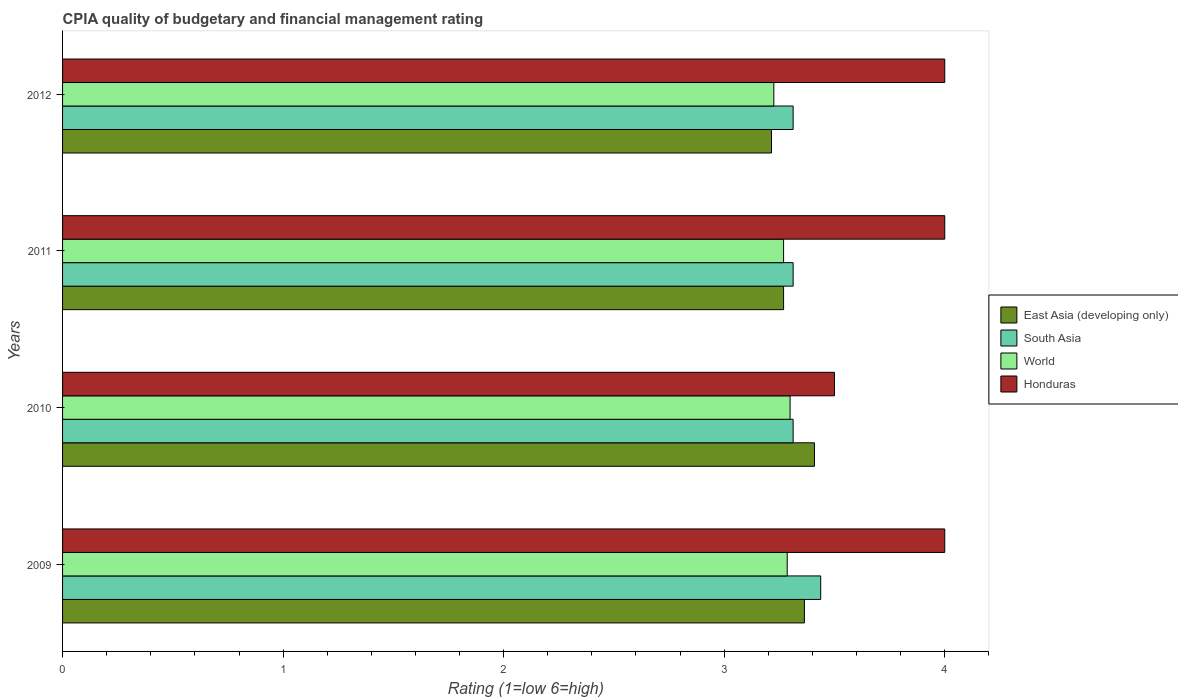How many bars are there on the 3rd tick from the top?
Offer a terse response. 4. What is the label of the 4th group of bars from the top?
Give a very brief answer. 2009. In how many cases, is the number of bars for a given year not equal to the number of legend labels?
Offer a very short reply. 0. What is the CPIA rating in Honduras in 2011?
Keep it short and to the point. 4. Across all years, what is the maximum CPIA rating in South Asia?
Provide a succinct answer. 3.44. Across all years, what is the minimum CPIA rating in World?
Offer a very short reply. 3.23. In which year was the CPIA rating in South Asia maximum?
Your response must be concise. 2009. In which year was the CPIA rating in Honduras minimum?
Provide a succinct answer. 2010. What is the difference between the CPIA rating in South Asia in 2009 and that in 2012?
Your answer should be very brief. 0.12. What is the difference between the CPIA rating in South Asia in 2009 and the CPIA rating in World in 2011?
Provide a short and direct response. 0.17. What is the average CPIA rating in Honduras per year?
Your response must be concise. 3.88. In the year 2011, what is the difference between the CPIA rating in World and CPIA rating in South Asia?
Ensure brevity in your answer.  -0.04. What is the ratio of the CPIA rating in World in 2009 to that in 2011?
Your answer should be compact. 1.01. Is the difference between the CPIA rating in World in 2009 and 2011 greater than the difference between the CPIA rating in South Asia in 2009 and 2011?
Provide a short and direct response. No. What is the difference between the highest and the second highest CPIA rating in East Asia (developing only)?
Keep it short and to the point. 0.05. Is the sum of the CPIA rating in World in 2009 and 2010 greater than the maximum CPIA rating in East Asia (developing only) across all years?
Offer a terse response. Yes. Is it the case that in every year, the sum of the CPIA rating in South Asia and CPIA rating in East Asia (developing only) is greater than the sum of CPIA rating in World and CPIA rating in Honduras?
Give a very brief answer. No. What does the 2nd bar from the top in 2009 represents?
Make the answer very short. World. What does the 4th bar from the bottom in 2009 represents?
Offer a terse response. Honduras. Is it the case that in every year, the sum of the CPIA rating in World and CPIA rating in South Asia is greater than the CPIA rating in East Asia (developing only)?
Your response must be concise. Yes. How many bars are there?
Keep it short and to the point. 16. Are the values on the major ticks of X-axis written in scientific E-notation?
Offer a terse response. No. Where does the legend appear in the graph?
Make the answer very short. Center right. How are the legend labels stacked?
Your answer should be compact. Vertical. What is the title of the graph?
Provide a short and direct response. CPIA quality of budgetary and financial management rating. Does "Guatemala" appear as one of the legend labels in the graph?
Your answer should be compact. No. What is the label or title of the X-axis?
Offer a terse response. Rating (1=low 6=high). What is the label or title of the Y-axis?
Provide a succinct answer. Years. What is the Rating (1=low 6=high) of East Asia (developing only) in 2009?
Offer a very short reply. 3.36. What is the Rating (1=low 6=high) in South Asia in 2009?
Your answer should be very brief. 3.44. What is the Rating (1=low 6=high) in World in 2009?
Your answer should be very brief. 3.29. What is the Rating (1=low 6=high) of Honduras in 2009?
Provide a succinct answer. 4. What is the Rating (1=low 6=high) in East Asia (developing only) in 2010?
Give a very brief answer. 3.41. What is the Rating (1=low 6=high) in South Asia in 2010?
Offer a terse response. 3.31. What is the Rating (1=low 6=high) in World in 2010?
Your response must be concise. 3.3. What is the Rating (1=low 6=high) in East Asia (developing only) in 2011?
Provide a short and direct response. 3.27. What is the Rating (1=low 6=high) of South Asia in 2011?
Ensure brevity in your answer.  3.31. What is the Rating (1=low 6=high) in World in 2011?
Provide a short and direct response. 3.27. What is the Rating (1=low 6=high) in East Asia (developing only) in 2012?
Give a very brief answer. 3.21. What is the Rating (1=low 6=high) of South Asia in 2012?
Provide a short and direct response. 3.31. What is the Rating (1=low 6=high) of World in 2012?
Ensure brevity in your answer.  3.23. What is the Rating (1=low 6=high) of Honduras in 2012?
Make the answer very short. 4. Across all years, what is the maximum Rating (1=low 6=high) of East Asia (developing only)?
Keep it short and to the point. 3.41. Across all years, what is the maximum Rating (1=low 6=high) in South Asia?
Offer a very short reply. 3.44. Across all years, what is the maximum Rating (1=low 6=high) in World?
Offer a very short reply. 3.3. Across all years, what is the minimum Rating (1=low 6=high) in East Asia (developing only)?
Offer a terse response. 3.21. Across all years, what is the minimum Rating (1=low 6=high) of South Asia?
Your response must be concise. 3.31. Across all years, what is the minimum Rating (1=low 6=high) of World?
Offer a terse response. 3.23. Across all years, what is the minimum Rating (1=low 6=high) of Honduras?
Ensure brevity in your answer.  3.5. What is the total Rating (1=low 6=high) of East Asia (developing only) in the graph?
Provide a succinct answer. 13.26. What is the total Rating (1=low 6=high) of South Asia in the graph?
Make the answer very short. 13.38. What is the total Rating (1=low 6=high) of World in the graph?
Offer a terse response. 13.08. What is the total Rating (1=low 6=high) in Honduras in the graph?
Offer a very short reply. 15.5. What is the difference between the Rating (1=low 6=high) of East Asia (developing only) in 2009 and that in 2010?
Your response must be concise. -0.05. What is the difference between the Rating (1=low 6=high) of South Asia in 2009 and that in 2010?
Make the answer very short. 0.12. What is the difference between the Rating (1=low 6=high) in World in 2009 and that in 2010?
Provide a succinct answer. -0.01. What is the difference between the Rating (1=low 6=high) of East Asia (developing only) in 2009 and that in 2011?
Ensure brevity in your answer.  0.09. What is the difference between the Rating (1=low 6=high) of South Asia in 2009 and that in 2011?
Provide a short and direct response. 0.12. What is the difference between the Rating (1=low 6=high) in World in 2009 and that in 2011?
Give a very brief answer. 0.02. What is the difference between the Rating (1=low 6=high) in East Asia (developing only) in 2009 and that in 2012?
Give a very brief answer. 0.15. What is the difference between the Rating (1=low 6=high) of World in 2009 and that in 2012?
Offer a terse response. 0.06. What is the difference between the Rating (1=low 6=high) in East Asia (developing only) in 2010 and that in 2011?
Keep it short and to the point. 0.14. What is the difference between the Rating (1=low 6=high) of World in 2010 and that in 2011?
Offer a terse response. 0.03. What is the difference between the Rating (1=low 6=high) of East Asia (developing only) in 2010 and that in 2012?
Offer a terse response. 0.19. What is the difference between the Rating (1=low 6=high) of South Asia in 2010 and that in 2012?
Provide a succinct answer. 0. What is the difference between the Rating (1=low 6=high) in World in 2010 and that in 2012?
Provide a short and direct response. 0.07. What is the difference between the Rating (1=low 6=high) in East Asia (developing only) in 2011 and that in 2012?
Provide a succinct answer. 0.05. What is the difference between the Rating (1=low 6=high) in South Asia in 2011 and that in 2012?
Provide a short and direct response. 0. What is the difference between the Rating (1=low 6=high) in World in 2011 and that in 2012?
Your answer should be compact. 0.04. What is the difference between the Rating (1=low 6=high) in Honduras in 2011 and that in 2012?
Your response must be concise. 0. What is the difference between the Rating (1=low 6=high) of East Asia (developing only) in 2009 and the Rating (1=low 6=high) of South Asia in 2010?
Your response must be concise. 0.05. What is the difference between the Rating (1=low 6=high) of East Asia (developing only) in 2009 and the Rating (1=low 6=high) of World in 2010?
Make the answer very short. 0.06. What is the difference between the Rating (1=low 6=high) in East Asia (developing only) in 2009 and the Rating (1=low 6=high) in Honduras in 2010?
Keep it short and to the point. -0.14. What is the difference between the Rating (1=low 6=high) in South Asia in 2009 and the Rating (1=low 6=high) in World in 2010?
Offer a terse response. 0.14. What is the difference between the Rating (1=low 6=high) of South Asia in 2009 and the Rating (1=low 6=high) of Honduras in 2010?
Provide a succinct answer. -0.06. What is the difference between the Rating (1=low 6=high) of World in 2009 and the Rating (1=low 6=high) of Honduras in 2010?
Offer a terse response. -0.21. What is the difference between the Rating (1=low 6=high) in East Asia (developing only) in 2009 and the Rating (1=low 6=high) in South Asia in 2011?
Offer a very short reply. 0.05. What is the difference between the Rating (1=low 6=high) of East Asia (developing only) in 2009 and the Rating (1=low 6=high) of World in 2011?
Your answer should be compact. 0.09. What is the difference between the Rating (1=low 6=high) in East Asia (developing only) in 2009 and the Rating (1=low 6=high) in Honduras in 2011?
Make the answer very short. -0.64. What is the difference between the Rating (1=low 6=high) in South Asia in 2009 and the Rating (1=low 6=high) in World in 2011?
Ensure brevity in your answer.  0.17. What is the difference between the Rating (1=low 6=high) of South Asia in 2009 and the Rating (1=low 6=high) of Honduras in 2011?
Offer a very short reply. -0.56. What is the difference between the Rating (1=low 6=high) in World in 2009 and the Rating (1=low 6=high) in Honduras in 2011?
Offer a terse response. -0.71. What is the difference between the Rating (1=low 6=high) in East Asia (developing only) in 2009 and the Rating (1=low 6=high) in South Asia in 2012?
Give a very brief answer. 0.05. What is the difference between the Rating (1=low 6=high) of East Asia (developing only) in 2009 and the Rating (1=low 6=high) of World in 2012?
Your answer should be compact. 0.14. What is the difference between the Rating (1=low 6=high) in East Asia (developing only) in 2009 and the Rating (1=low 6=high) in Honduras in 2012?
Give a very brief answer. -0.64. What is the difference between the Rating (1=low 6=high) of South Asia in 2009 and the Rating (1=low 6=high) of World in 2012?
Provide a succinct answer. 0.21. What is the difference between the Rating (1=low 6=high) of South Asia in 2009 and the Rating (1=low 6=high) of Honduras in 2012?
Give a very brief answer. -0.56. What is the difference between the Rating (1=low 6=high) in World in 2009 and the Rating (1=low 6=high) in Honduras in 2012?
Make the answer very short. -0.71. What is the difference between the Rating (1=low 6=high) of East Asia (developing only) in 2010 and the Rating (1=low 6=high) of South Asia in 2011?
Your answer should be compact. 0.1. What is the difference between the Rating (1=low 6=high) of East Asia (developing only) in 2010 and the Rating (1=low 6=high) of World in 2011?
Keep it short and to the point. 0.14. What is the difference between the Rating (1=low 6=high) in East Asia (developing only) in 2010 and the Rating (1=low 6=high) in Honduras in 2011?
Keep it short and to the point. -0.59. What is the difference between the Rating (1=low 6=high) of South Asia in 2010 and the Rating (1=low 6=high) of World in 2011?
Provide a short and direct response. 0.04. What is the difference between the Rating (1=low 6=high) in South Asia in 2010 and the Rating (1=low 6=high) in Honduras in 2011?
Your answer should be compact. -0.69. What is the difference between the Rating (1=low 6=high) in World in 2010 and the Rating (1=low 6=high) in Honduras in 2011?
Keep it short and to the point. -0.7. What is the difference between the Rating (1=low 6=high) of East Asia (developing only) in 2010 and the Rating (1=low 6=high) of South Asia in 2012?
Keep it short and to the point. 0.1. What is the difference between the Rating (1=low 6=high) of East Asia (developing only) in 2010 and the Rating (1=low 6=high) of World in 2012?
Offer a very short reply. 0.18. What is the difference between the Rating (1=low 6=high) of East Asia (developing only) in 2010 and the Rating (1=low 6=high) of Honduras in 2012?
Your answer should be very brief. -0.59. What is the difference between the Rating (1=low 6=high) in South Asia in 2010 and the Rating (1=low 6=high) in World in 2012?
Offer a very short reply. 0.09. What is the difference between the Rating (1=low 6=high) of South Asia in 2010 and the Rating (1=low 6=high) of Honduras in 2012?
Your answer should be compact. -0.69. What is the difference between the Rating (1=low 6=high) of World in 2010 and the Rating (1=low 6=high) of Honduras in 2012?
Provide a short and direct response. -0.7. What is the difference between the Rating (1=low 6=high) of East Asia (developing only) in 2011 and the Rating (1=low 6=high) of South Asia in 2012?
Your response must be concise. -0.04. What is the difference between the Rating (1=low 6=high) in East Asia (developing only) in 2011 and the Rating (1=low 6=high) in World in 2012?
Give a very brief answer. 0.04. What is the difference between the Rating (1=low 6=high) of East Asia (developing only) in 2011 and the Rating (1=low 6=high) of Honduras in 2012?
Ensure brevity in your answer.  -0.73. What is the difference between the Rating (1=low 6=high) of South Asia in 2011 and the Rating (1=low 6=high) of World in 2012?
Give a very brief answer. 0.09. What is the difference between the Rating (1=low 6=high) of South Asia in 2011 and the Rating (1=low 6=high) of Honduras in 2012?
Offer a terse response. -0.69. What is the difference between the Rating (1=low 6=high) of World in 2011 and the Rating (1=low 6=high) of Honduras in 2012?
Offer a terse response. -0.73. What is the average Rating (1=low 6=high) of East Asia (developing only) per year?
Ensure brevity in your answer.  3.31. What is the average Rating (1=low 6=high) in South Asia per year?
Keep it short and to the point. 3.34. What is the average Rating (1=low 6=high) of World per year?
Your answer should be compact. 3.27. What is the average Rating (1=low 6=high) of Honduras per year?
Keep it short and to the point. 3.88. In the year 2009, what is the difference between the Rating (1=low 6=high) in East Asia (developing only) and Rating (1=low 6=high) in South Asia?
Make the answer very short. -0.07. In the year 2009, what is the difference between the Rating (1=low 6=high) in East Asia (developing only) and Rating (1=low 6=high) in World?
Give a very brief answer. 0.08. In the year 2009, what is the difference between the Rating (1=low 6=high) of East Asia (developing only) and Rating (1=low 6=high) of Honduras?
Your answer should be very brief. -0.64. In the year 2009, what is the difference between the Rating (1=low 6=high) in South Asia and Rating (1=low 6=high) in World?
Keep it short and to the point. 0.15. In the year 2009, what is the difference between the Rating (1=low 6=high) in South Asia and Rating (1=low 6=high) in Honduras?
Offer a very short reply. -0.56. In the year 2009, what is the difference between the Rating (1=low 6=high) in World and Rating (1=low 6=high) in Honduras?
Offer a terse response. -0.71. In the year 2010, what is the difference between the Rating (1=low 6=high) in East Asia (developing only) and Rating (1=low 6=high) in South Asia?
Your answer should be compact. 0.1. In the year 2010, what is the difference between the Rating (1=low 6=high) in East Asia (developing only) and Rating (1=low 6=high) in World?
Give a very brief answer. 0.11. In the year 2010, what is the difference between the Rating (1=low 6=high) in East Asia (developing only) and Rating (1=low 6=high) in Honduras?
Make the answer very short. -0.09. In the year 2010, what is the difference between the Rating (1=low 6=high) of South Asia and Rating (1=low 6=high) of World?
Your answer should be very brief. 0.01. In the year 2010, what is the difference between the Rating (1=low 6=high) of South Asia and Rating (1=low 6=high) of Honduras?
Offer a very short reply. -0.19. In the year 2010, what is the difference between the Rating (1=low 6=high) in World and Rating (1=low 6=high) in Honduras?
Offer a terse response. -0.2. In the year 2011, what is the difference between the Rating (1=low 6=high) in East Asia (developing only) and Rating (1=low 6=high) in South Asia?
Make the answer very short. -0.04. In the year 2011, what is the difference between the Rating (1=low 6=high) of East Asia (developing only) and Rating (1=low 6=high) of Honduras?
Your answer should be compact. -0.73. In the year 2011, what is the difference between the Rating (1=low 6=high) in South Asia and Rating (1=low 6=high) in World?
Your answer should be very brief. 0.04. In the year 2011, what is the difference between the Rating (1=low 6=high) in South Asia and Rating (1=low 6=high) in Honduras?
Your answer should be compact. -0.69. In the year 2011, what is the difference between the Rating (1=low 6=high) of World and Rating (1=low 6=high) of Honduras?
Make the answer very short. -0.73. In the year 2012, what is the difference between the Rating (1=low 6=high) in East Asia (developing only) and Rating (1=low 6=high) in South Asia?
Your answer should be very brief. -0.1. In the year 2012, what is the difference between the Rating (1=low 6=high) of East Asia (developing only) and Rating (1=low 6=high) of World?
Provide a short and direct response. -0.01. In the year 2012, what is the difference between the Rating (1=low 6=high) in East Asia (developing only) and Rating (1=low 6=high) in Honduras?
Offer a terse response. -0.79. In the year 2012, what is the difference between the Rating (1=low 6=high) in South Asia and Rating (1=low 6=high) in World?
Provide a succinct answer. 0.09. In the year 2012, what is the difference between the Rating (1=low 6=high) in South Asia and Rating (1=low 6=high) in Honduras?
Your answer should be compact. -0.69. In the year 2012, what is the difference between the Rating (1=low 6=high) of World and Rating (1=low 6=high) of Honduras?
Make the answer very short. -0.78. What is the ratio of the Rating (1=low 6=high) in East Asia (developing only) in 2009 to that in 2010?
Make the answer very short. 0.99. What is the ratio of the Rating (1=low 6=high) of South Asia in 2009 to that in 2010?
Make the answer very short. 1.04. What is the ratio of the Rating (1=low 6=high) in World in 2009 to that in 2010?
Provide a succinct answer. 1. What is the ratio of the Rating (1=low 6=high) in Honduras in 2009 to that in 2010?
Your response must be concise. 1.14. What is the ratio of the Rating (1=low 6=high) in East Asia (developing only) in 2009 to that in 2011?
Make the answer very short. 1.03. What is the ratio of the Rating (1=low 6=high) in South Asia in 2009 to that in 2011?
Offer a terse response. 1.04. What is the ratio of the Rating (1=low 6=high) in East Asia (developing only) in 2009 to that in 2012?
Your response must be concise. 1.05. What is the ratio of the Rating (1=low 6=high) in South Asia in 2009 to that in 2012?
Make the answer very short. 1.04. What is the ratio of the Rating (1=low 6=high) of World in 2009 to that in 2012?
Your answer should be very brief. 1.02. What is the ratio of the Rating (1=low 6=high) in Honduras in 2009 to that in 2012?
Provide a succinct answer. 1. What is the ratio of the Rating (1=low 6=high) in East Asia (developing only) in 2010 to that in 2011?
Provide a succinct answer. 1.04. What is the ratio of the Rating (1=low 6=high) in East Asia (developing only) in 2010 to that in 2012?
Provide a short and direct response. 1.06. What is the ratio of the Rating (1=low 6=high) in World in 2010 to that in 2012?
Ensure brevity in your answer.  1.02. What is the ratio of the Rating (1=low 6=high) in Honduras in 2010 to that in 2012?
Provide a short and direct response. 0.88. What is the ratio of the Rating (1=low 6=high) in East Asia (developing only) in 2011 to that in 2012?
Your answer should be compact. 1.02. What is the ratio of the Rating (1=low 6=high) of World in 2011 to that in 2012?
Provide a short and direct response. 1.01. What is the difference between the highest and the second highest Rating (1=low 6=high) of East Asia (developing only)?
Ensure brevity in your answer.  0.05. What is the difference between the highest and the second highest Rating (1=low 6=high) of World?
Your answer should be compact. 0.01. What is the difference between the highest and the lowest Rating (1=low 6=high) in East Asia (developing only)?
Your answer should be compact. 0.19. What is the difference between the highest and the lowest Rating (1=low 6=high) of South Asia?
Provide a succinct answer. 0.12. What is the difference between the highest and the lowest Rating (1=low 6=high) in World?
Make the answer very short. 0.07. 